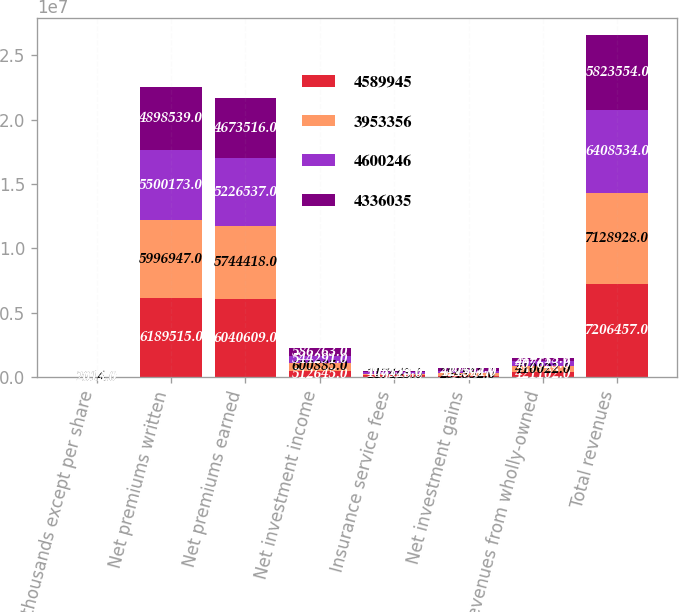Convert chart. <chart><loc_0><loc_0><loc_500><loc_500><stacked_bar_chart><ecel><fcel>(In thousands except per share<fcel>Net premiums written<fcel>Net premiums earned<fcel>Net investment income<fcel>Insurance service fees<fcel>Net investment gains<fcel>Revenues from wholly-owned<fcel>Total revenues<nl><fcel>4.58994e+06<fcel>2015<fcel>6.18952e+06<fcel>6.04061e+06<fcel>512645<fcel>139440<fcel>92324<fcel>421102<fcel>7.20646e+06<nl><fcel>3.95336e+06<fcel>2014<fcel>5.99695e+06<fcel>5.74442e+06<fcel>600885<fcel>117443<fcel>254852<fcel>410022<fcel>7.12893e+06<nl><fcel>4.60025e+06<fcel>2013<fcel>5.50017e+06<fcel>5.22654e+06<fcel>544291<fcel>107513<fcel>121544<fcel>407623<fcel>6.40853e+06<nl><fcel>4.33604e+06<fcel>2012<fcel>4.89854e+06<fcel>4.67352e+06<fcel>586763<fcel>103133<fcel>210465<fcel>247113<fcel>5.82355e+06<nl></chart> 